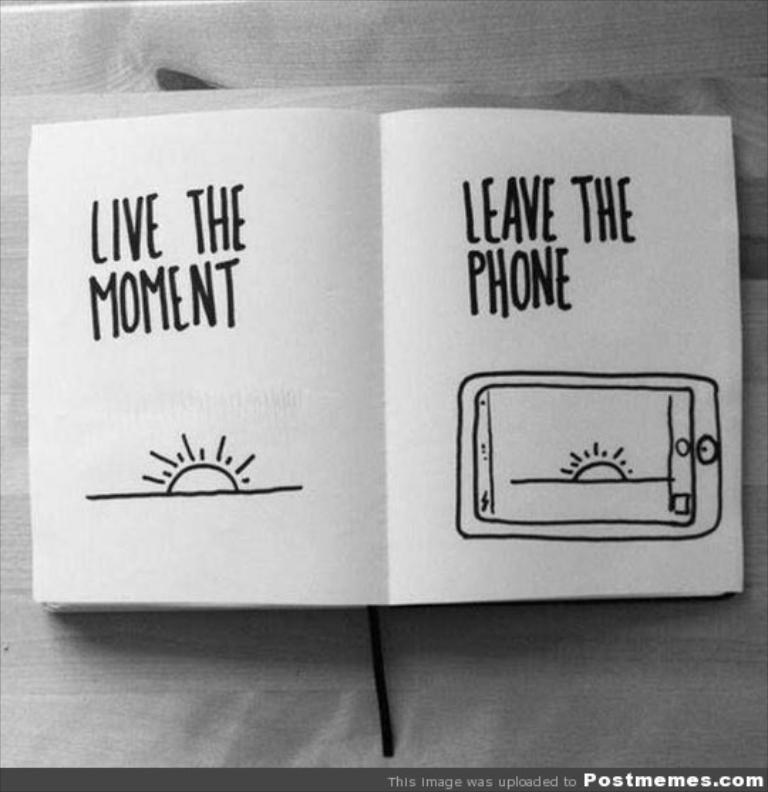<image>
Render a clear and concise summary of the photo. A book open, and on the pages it says Live the Moment. 